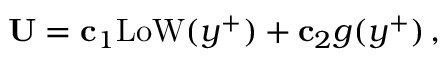<formula> <loc_0><loc_0><loc_500><loc_500>{ U } = { c } _ { 1 } L o W ( y ^ { + } ) + { c } _ { 2 } g ( y ^ { + } ) \, ,</formula> 